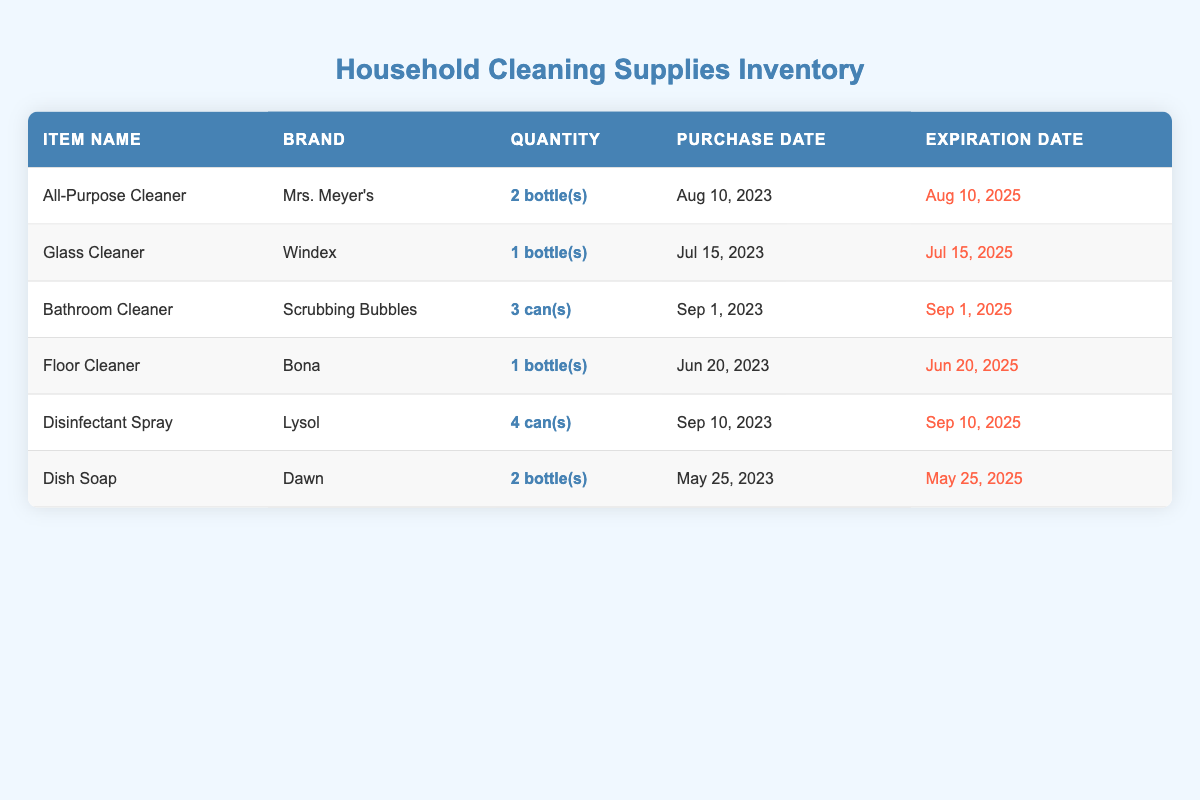What is the total quantity of all-purpose cleaner in the inventory? According to the table, there are 2 bottles of All-Purpose Cleaner listed under the quantity column.
Answer: 2 bottles How many different types of cleaning supplies are listed? The table lists six different cleaning supplies: All-Purpose Cleaner, Glass Cleaner, Bathroom Cleaner, Floor Cleaner, Disinfectant Spray, and Dish Soap, making a total of 6 types.
Answer: 6 Is there any cleaning supply that has a quantity greater than 2? Yes, the Disinfectant Spray has a quantity of 4, which is greater than 2.
Answer: Yes Which cleaning supply has the latest purchase date? The cleaning supply with the latest purchase date is Disinfectant Spray, which was purchased on September 10, 2023. This is compared against all other purchase dates in the table.
Answer: Disinfectant Spray What is the average quantity of cleaning supplies in the inventory? The total quantity of all cleaning supplies is 2 (All-Purpose) + 1 (Glass) + 3 (Bathroom) + 1 (Floor) + 4 (Disinfectant) + 2 (Dish) = 13. There are 6 types of supplies, so the average quantity is 13 divided by 6, which equals approximately 2.17.
Answer: 2.17 Does any of the cleaning supplies expire before July 2025? Yes, the Dish Soap expires on May 25, 2025, which is before July 2025.
Answer: Yes What is the difference in quantity between the cleaning supply with the most units and the one with the least? The supply with the most units is Disinfectant Spray with 4 cans, and the one with the least is Glass Cleaner with 1 bottle. The difference is 4 - 1 = 3.
Answer: 3 Which cleaning supply has an expiration date closest to now? The Glass Cleaner has an expiration date of July 15, 2025, which is the closest expiration date compared to others in the table when we consider the time now.
Answer: Glass Cleaner 